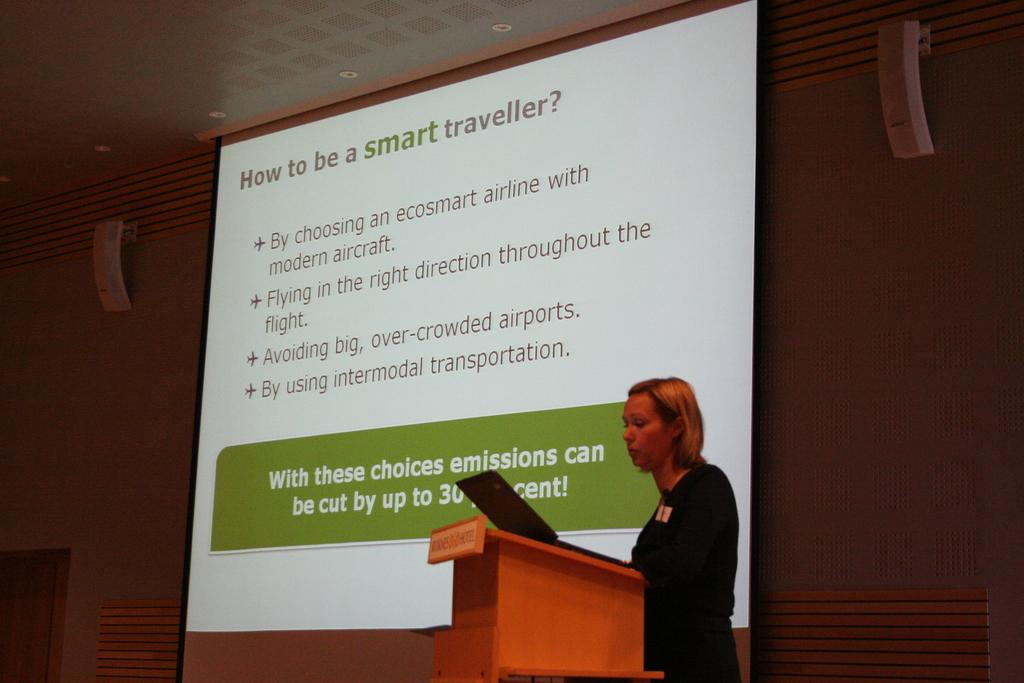Who is the main subject in the image? There is a woman in the image. What is the woman doing in the image? The woman is standing behind a podium. What object is on the podium with the woman? There is a laptop on the podium. What is visible on the screen behind the woman? The screen has text displayed on it. What can be seen in the background of the image? There is a wall in the background, and the wall has a door. What type of holiday is the woman celebrating in the image? There is no indication of a holiday in the image; it features a woman standing behind a podium with a laptop and a screen displaying text. What color is the ink used to write the text on the screen? The image does not provide information about the color of the ink used to write the text on the screen. 